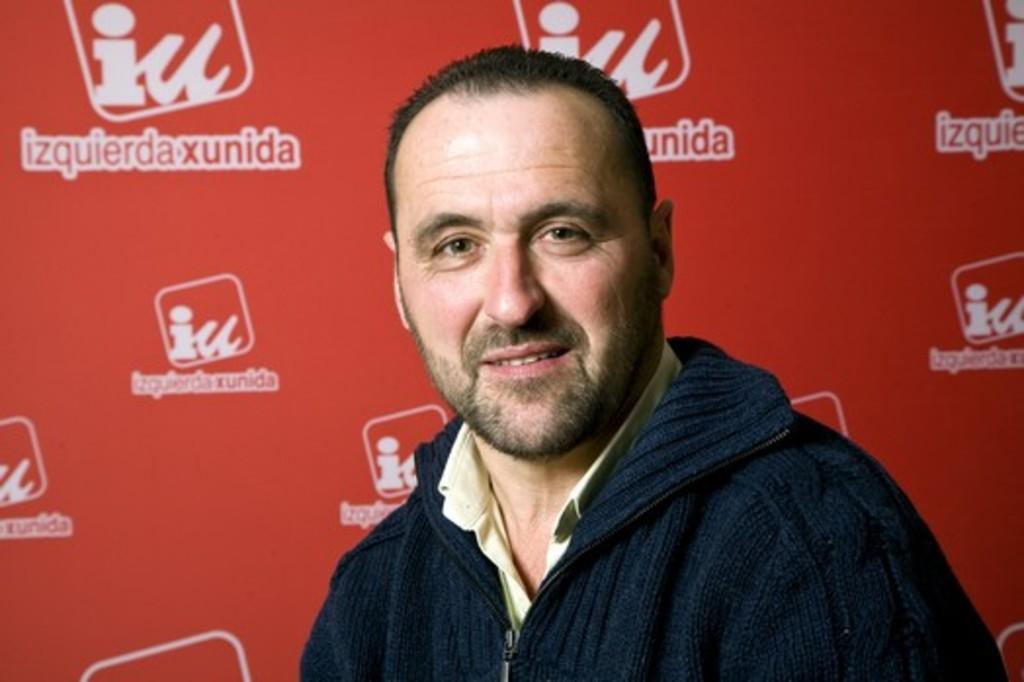Who is present in the image? There is a man in the image. What is the man wearing? The man is wearing a blue jacket. What can be seen in the background behind the man? There is a hoarding visible behind the man. What type of snail can be seen crawling on the man's blue jacket in the image? There is no snail present on the man's blue jacket in the image. Is there a train visible in the image? No, there is no train present in the image. 